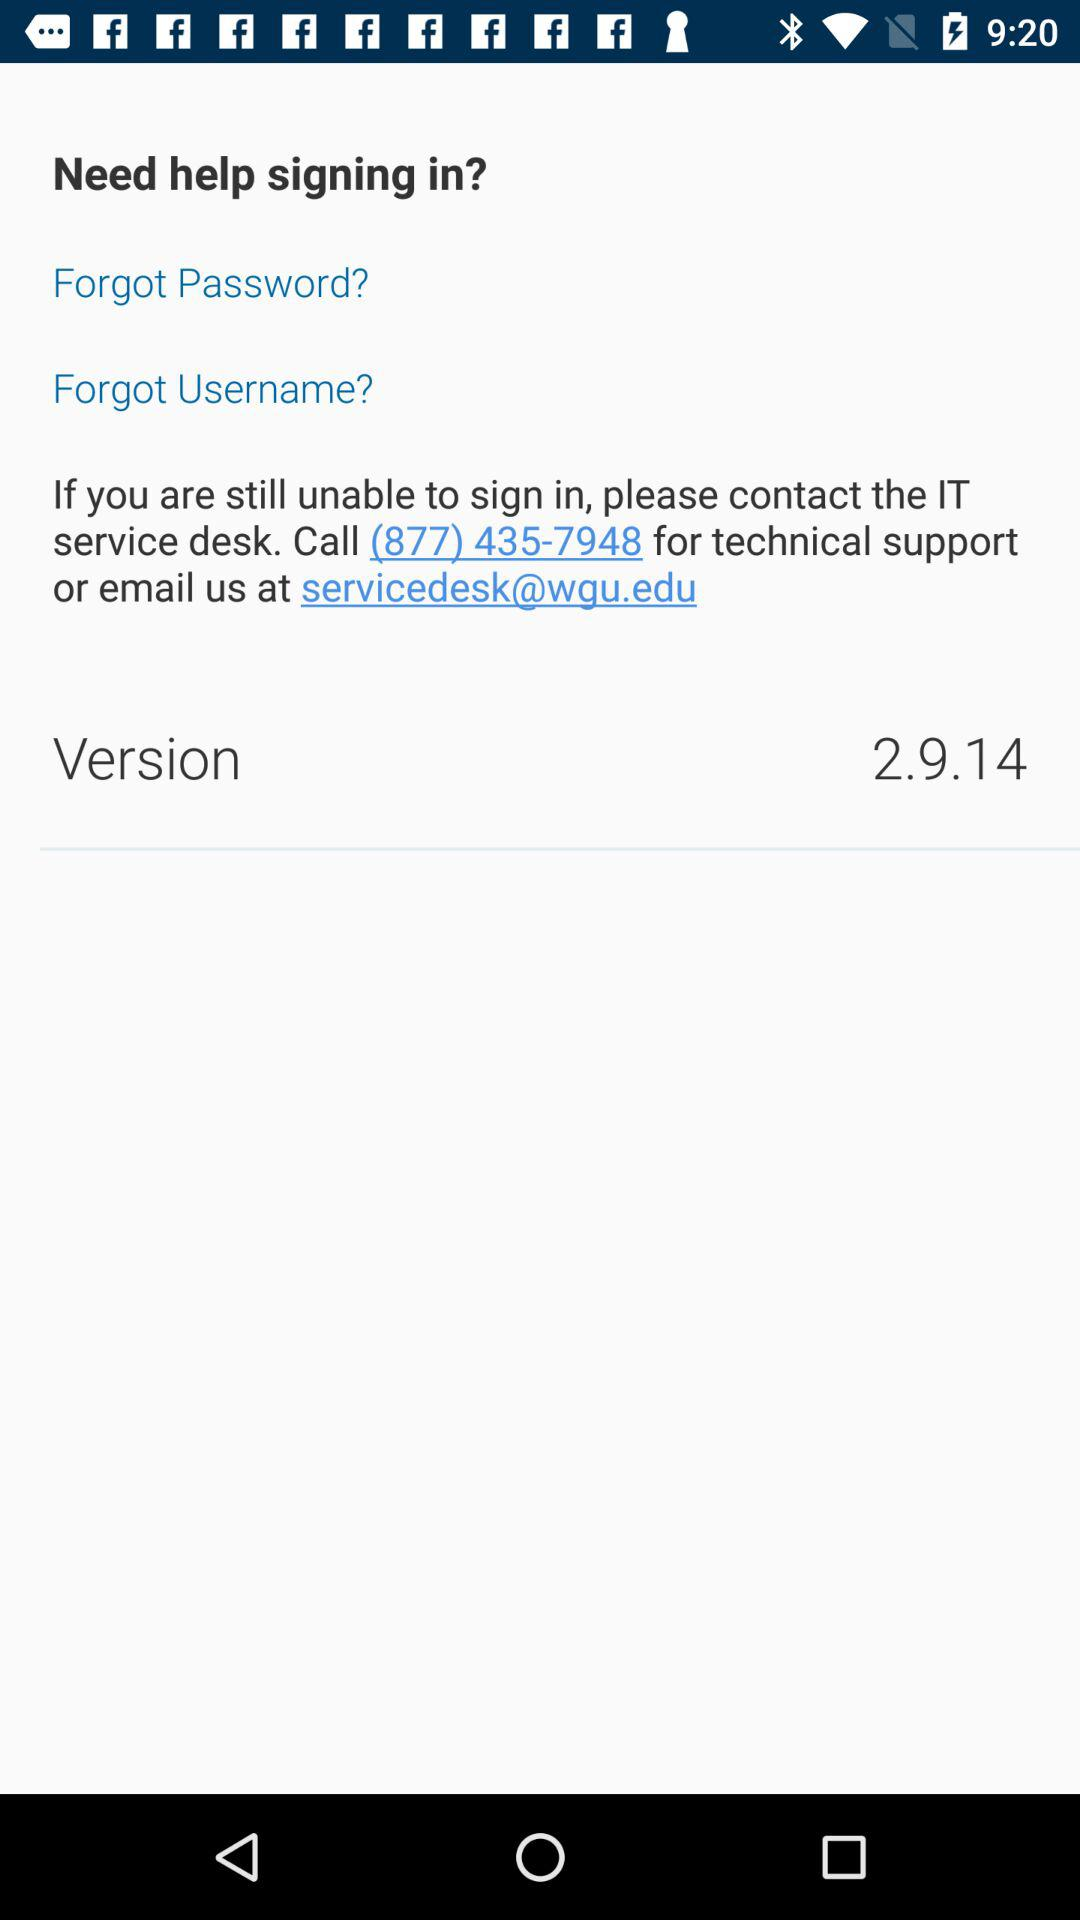What is the email address for contacting the IT service desk? The email address for contacting the IT service desk is servicedesk@wgu.edu. 